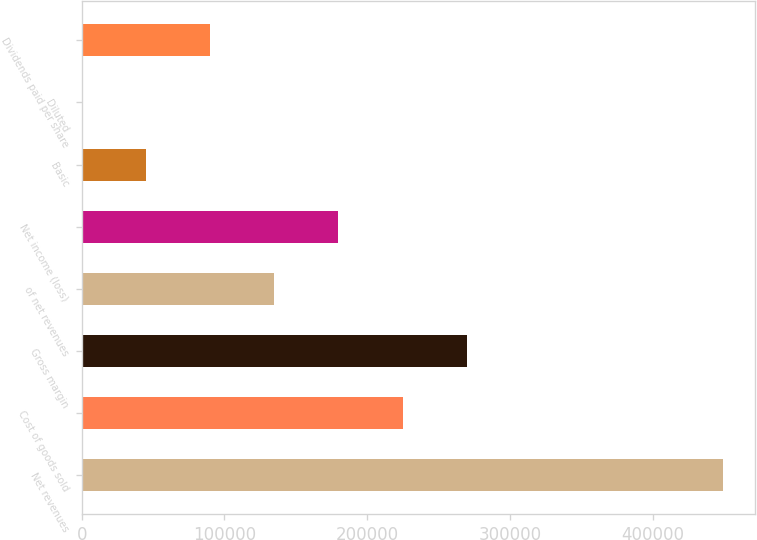<chart> <loc_0><loc_0><loc_500><loc_500><bar_chart><fcel>Net revenues<fcel>Cost of goods sold<fcel>Gross margin<fcel>of net revenues<fcel>Net income (loss)<fcel>Basic<fcel>Diluted<fcel>Dividends paid per share<nl><fcel>449246<fcel>224623<fcel>269548<fcel>134774<fcel>179698<fcel>44924.7<fcel>0.13<fcel>89849.3<nl></chart> 